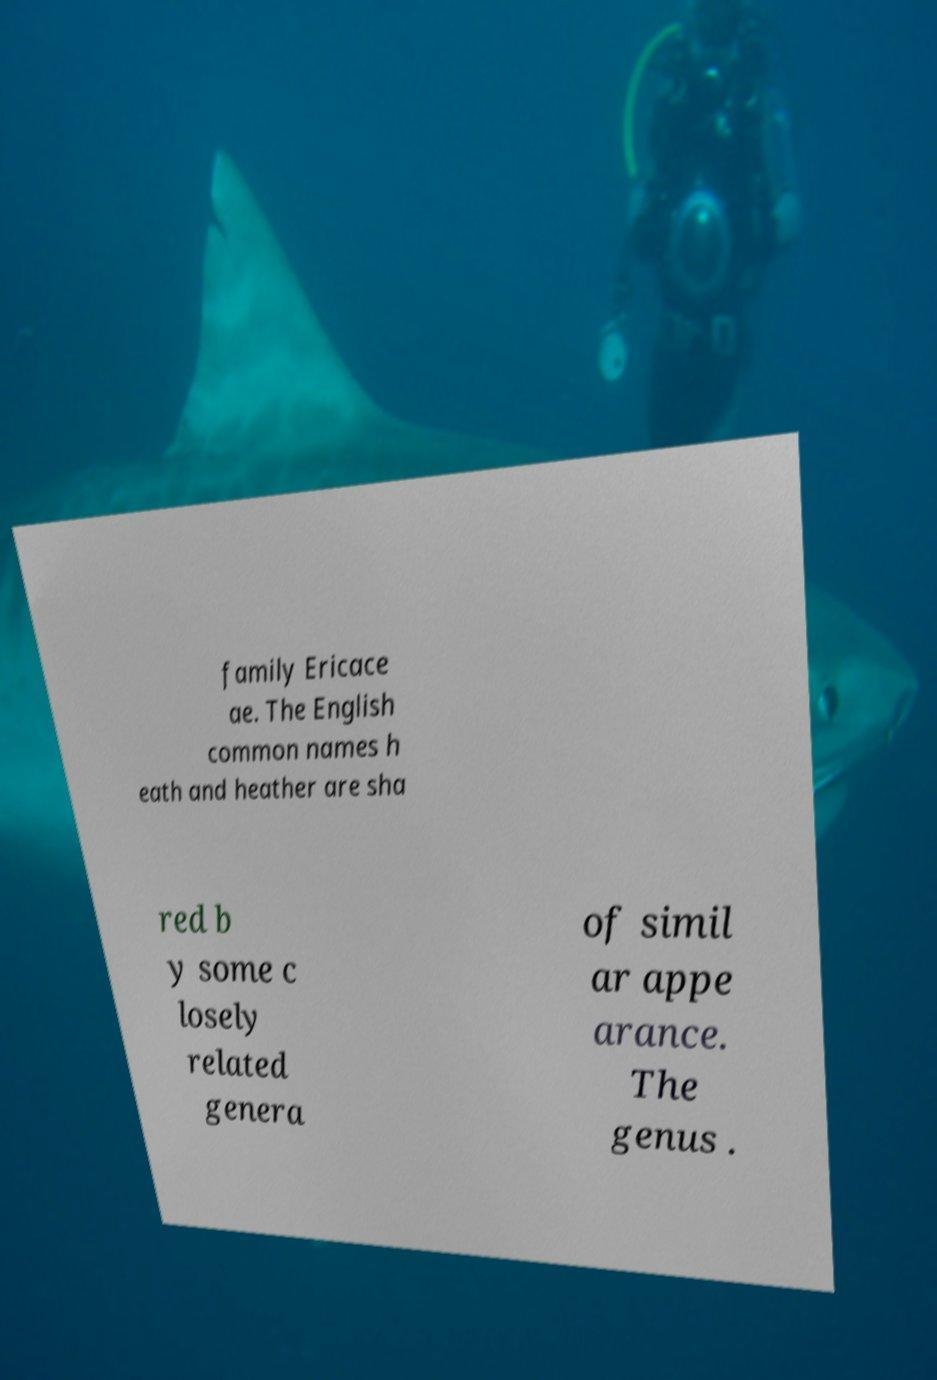Could you assist in decoding the text presented in this image and type it out clearly? family Ericace ae. The English common names h eath and heather are sha red b y some c losely related genera of simil ar appe arance. The genus . 